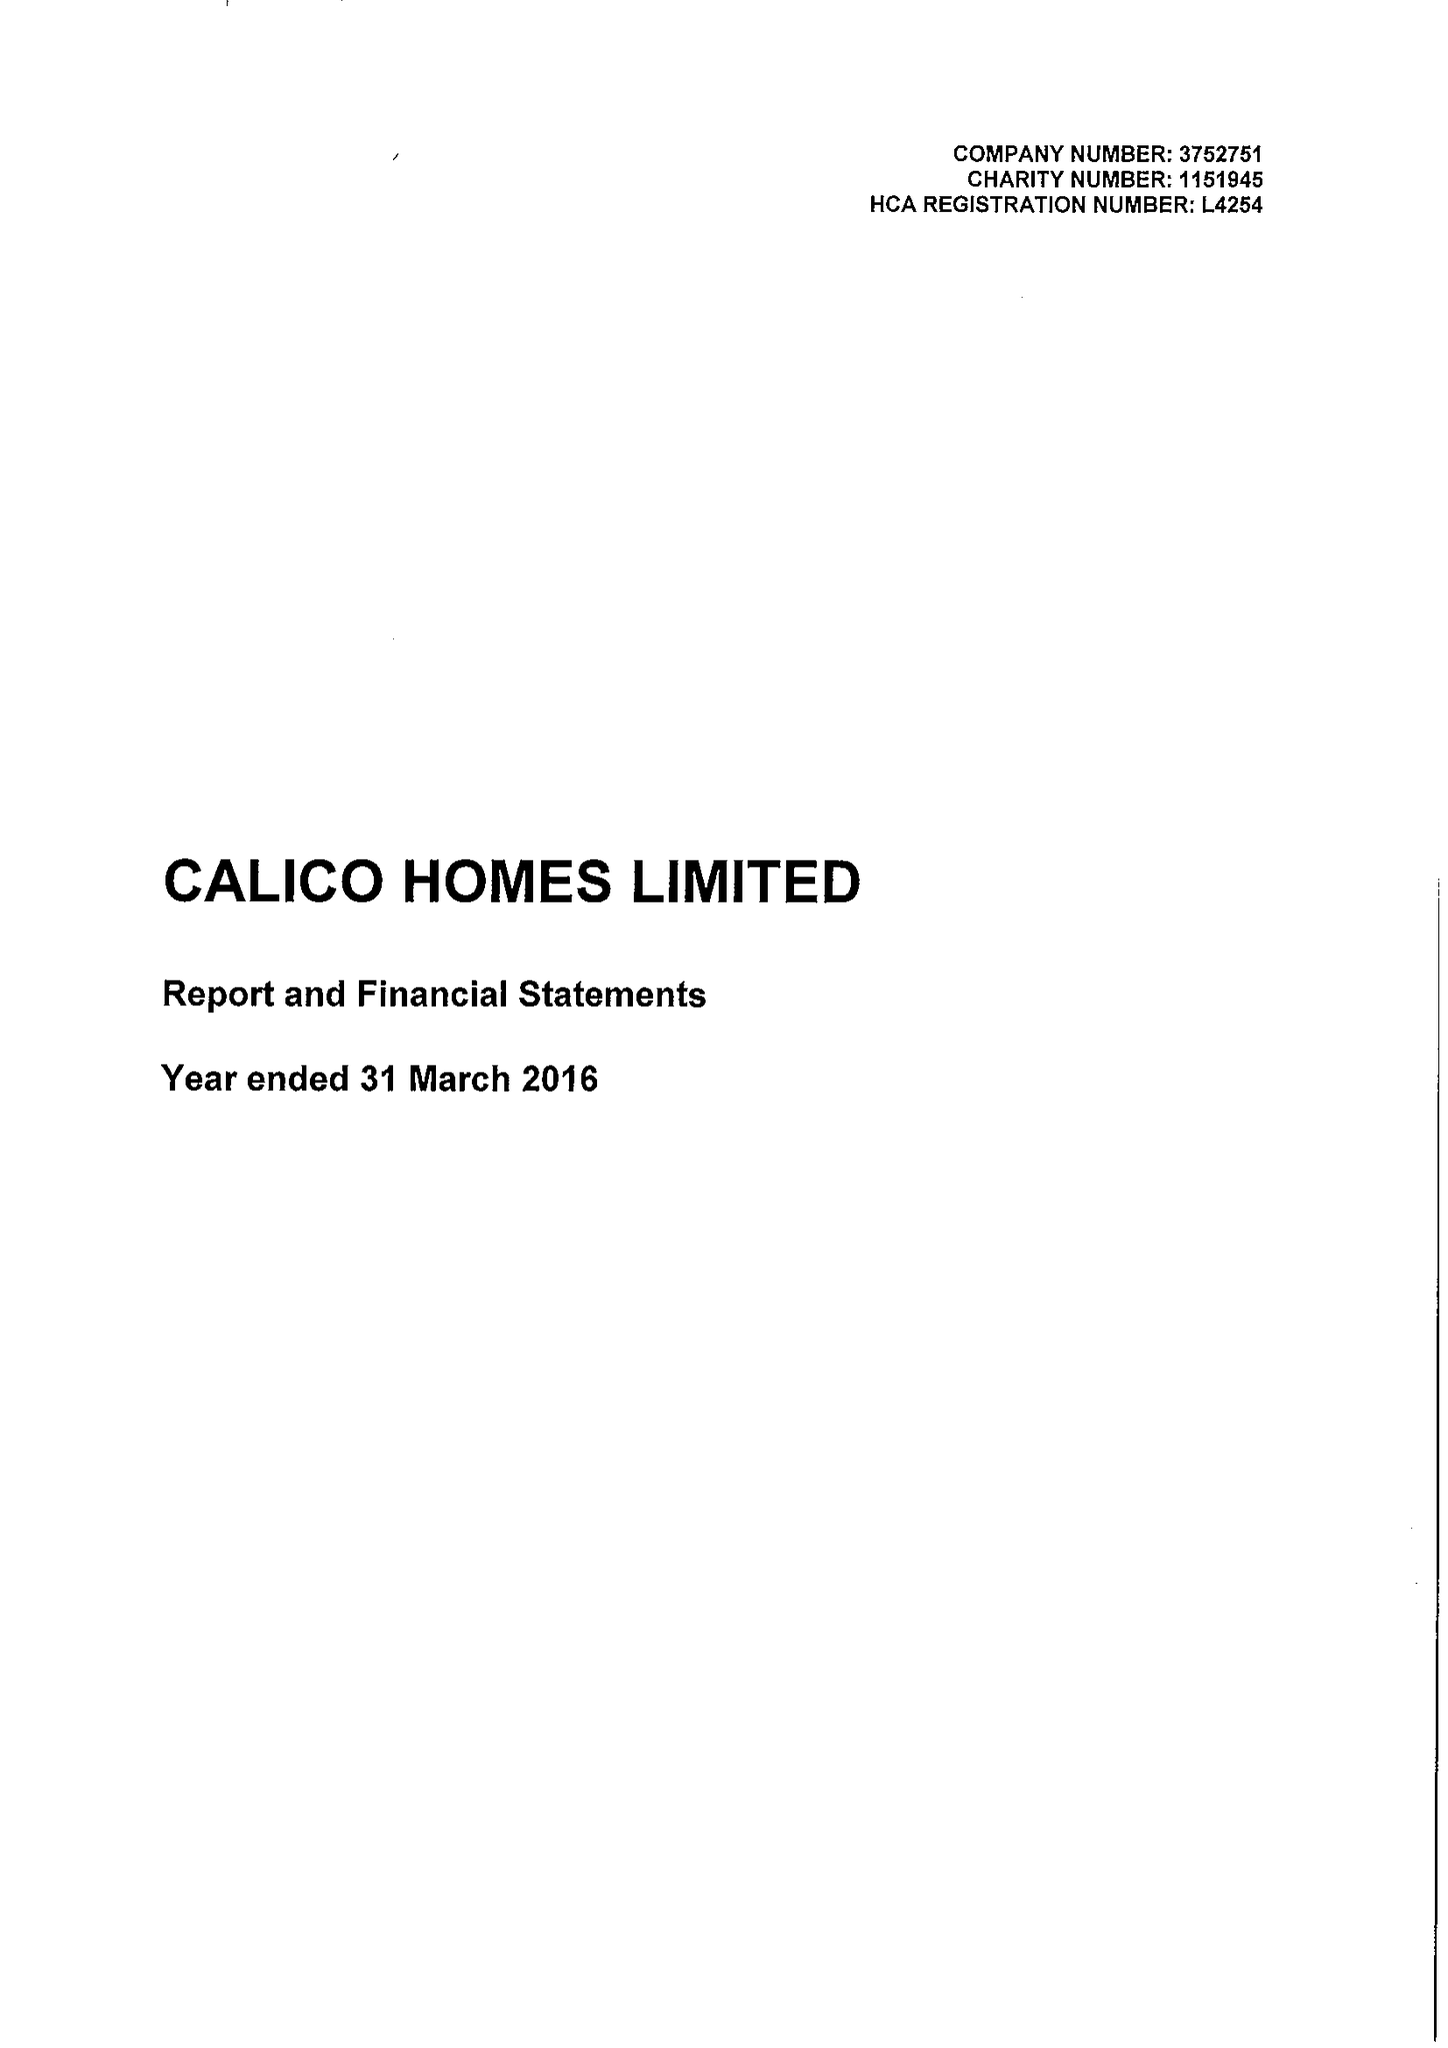What is the value for the income_annually_in_british_pounds?
Answer the question using a single word or phrase. 23604000.00 